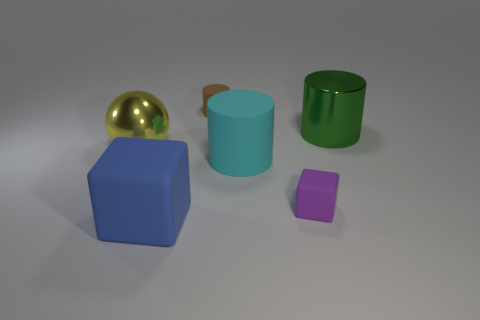Subtract all large metallic cylinders. How many cylinders are left? 2 Subtract 1 cylinders. How many cylinders are left? 2 Add 4 tiny matte things. How many objects exist? 10 Subtract all cubes. How many objects are left? 4 Add 4 big objects. How many big objects exist? 8 Subtract 0 purple balls. How many objects are left? 6 Subtract all tiny cylinders. Subtract all large cyan rubber cylinders. How many objects are left? 4 Add 2 tiny things. How many tiny things are left? 4 